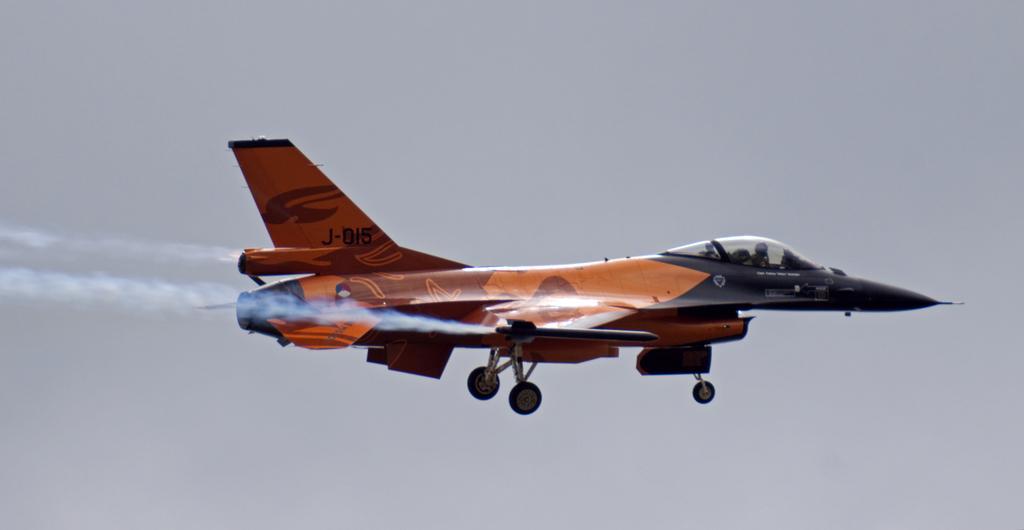How would you summarize this image in a sentence or two? In this image we can see an airplane is flying and in the background, we can see the sky. 